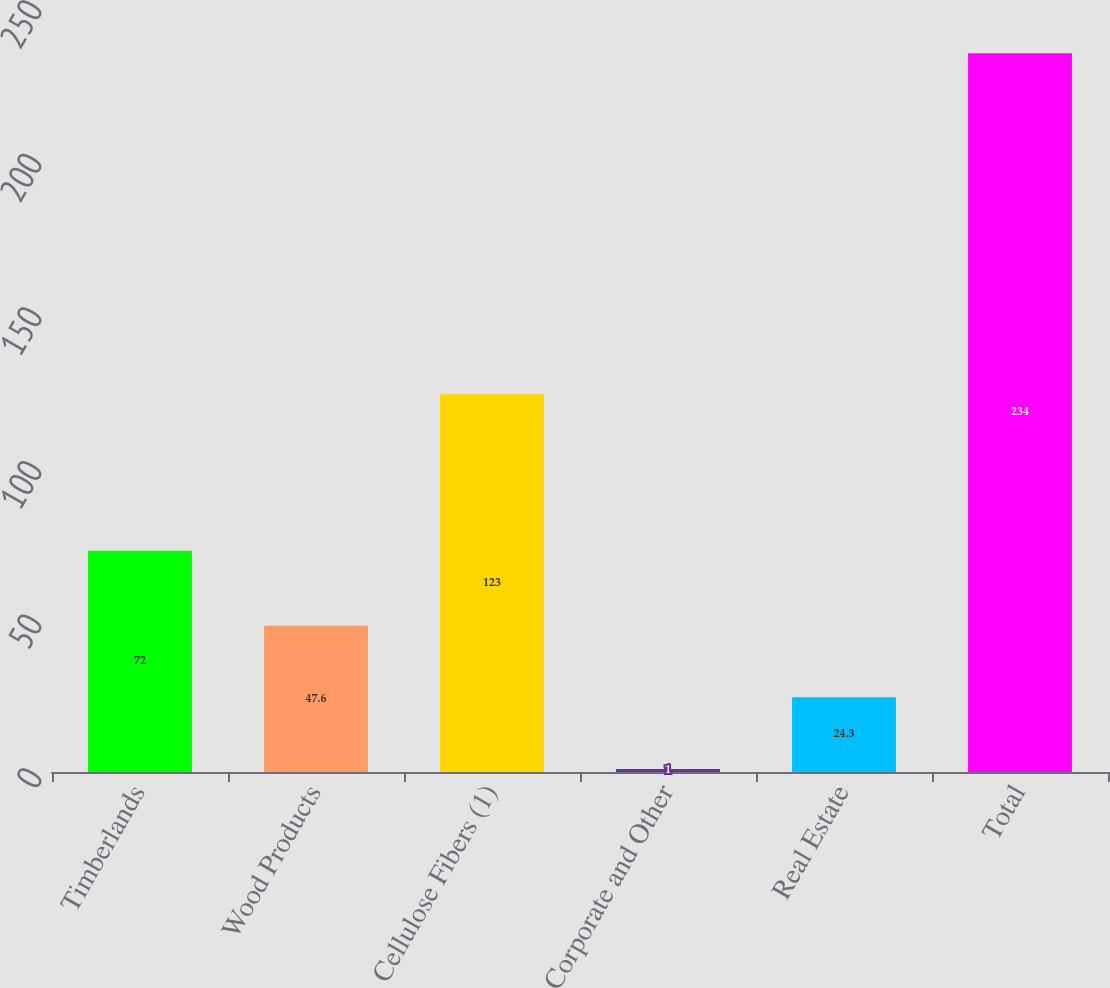Convert chart to OTSL. <chart><loc_0><loc_0><loc_500><loc_500><bar_chart><fcel>Timberlands<fcel>Wood Products<fcel>Cellulose Fibers (1)<fcel>Corporate and Other<fcel>Real Estate<fcel>Total<nl><fcel>72<fcel>47.6<fcel>123<fcel>1<fcel>24.3<fcel>234<nl></chart> 